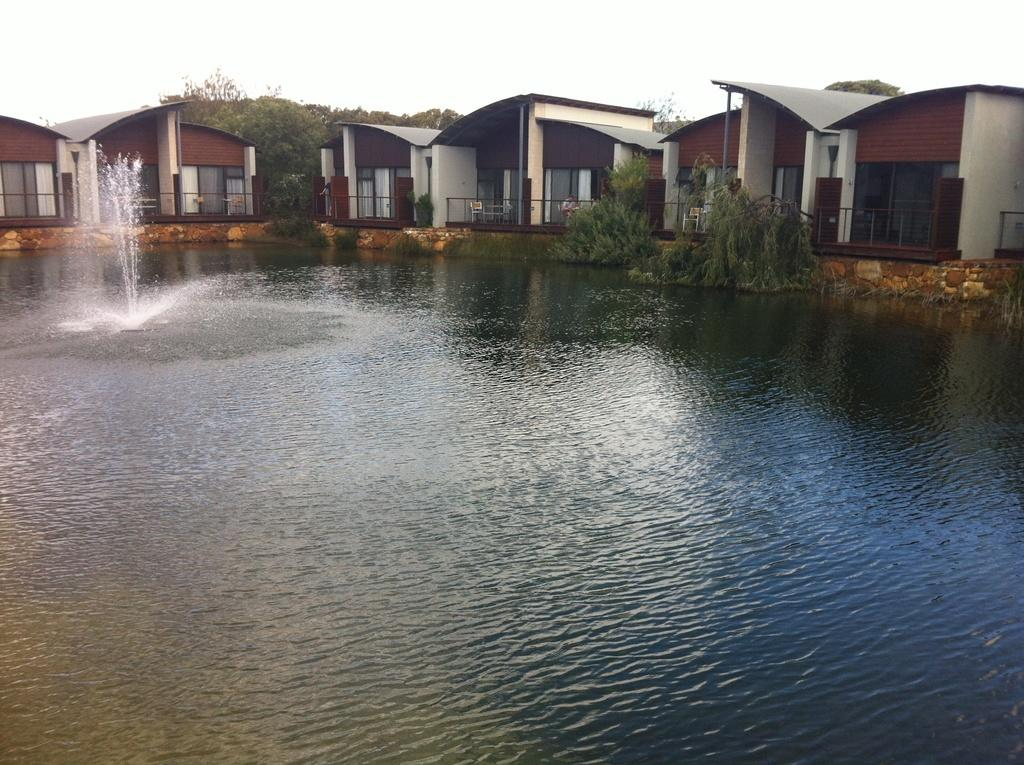What is the primary element present in the image? There is water in the image. What celestial bodies can be seen in the image? There are planets visible in the image. What type of structures are present in the image? There are houses in the image. What part of the natural environment is visible in the image? The sky is visible in the image. Can you tell me how many girls are swimming with the frog in the image? There are no girls or frogs present in the image; it features water, planets, houses, and the sky. What type of division is being performed on the planets in the image? There is no division being performed on the planets in the image; they are simply visible. 